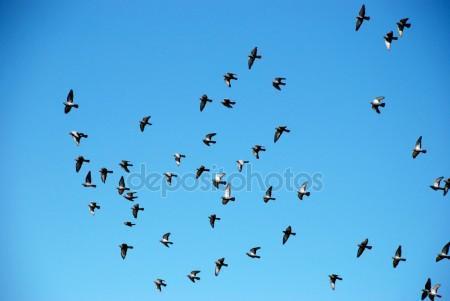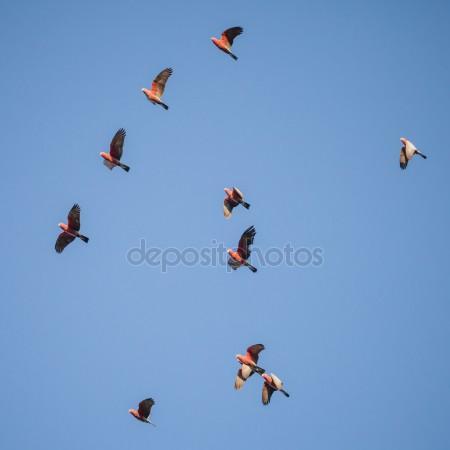The first image is the image on the left, the second image is the image on the right. Assess this claim about the two images: "Two birds are flying the air in the image on the left". Correct or not? Answer yes or no. No. The first image is the image on the left, the second image is the image on the right. Analyze the images presented: Is the assertion "The left photo depicts only two parrots." valid? Answer yes or no. No. 